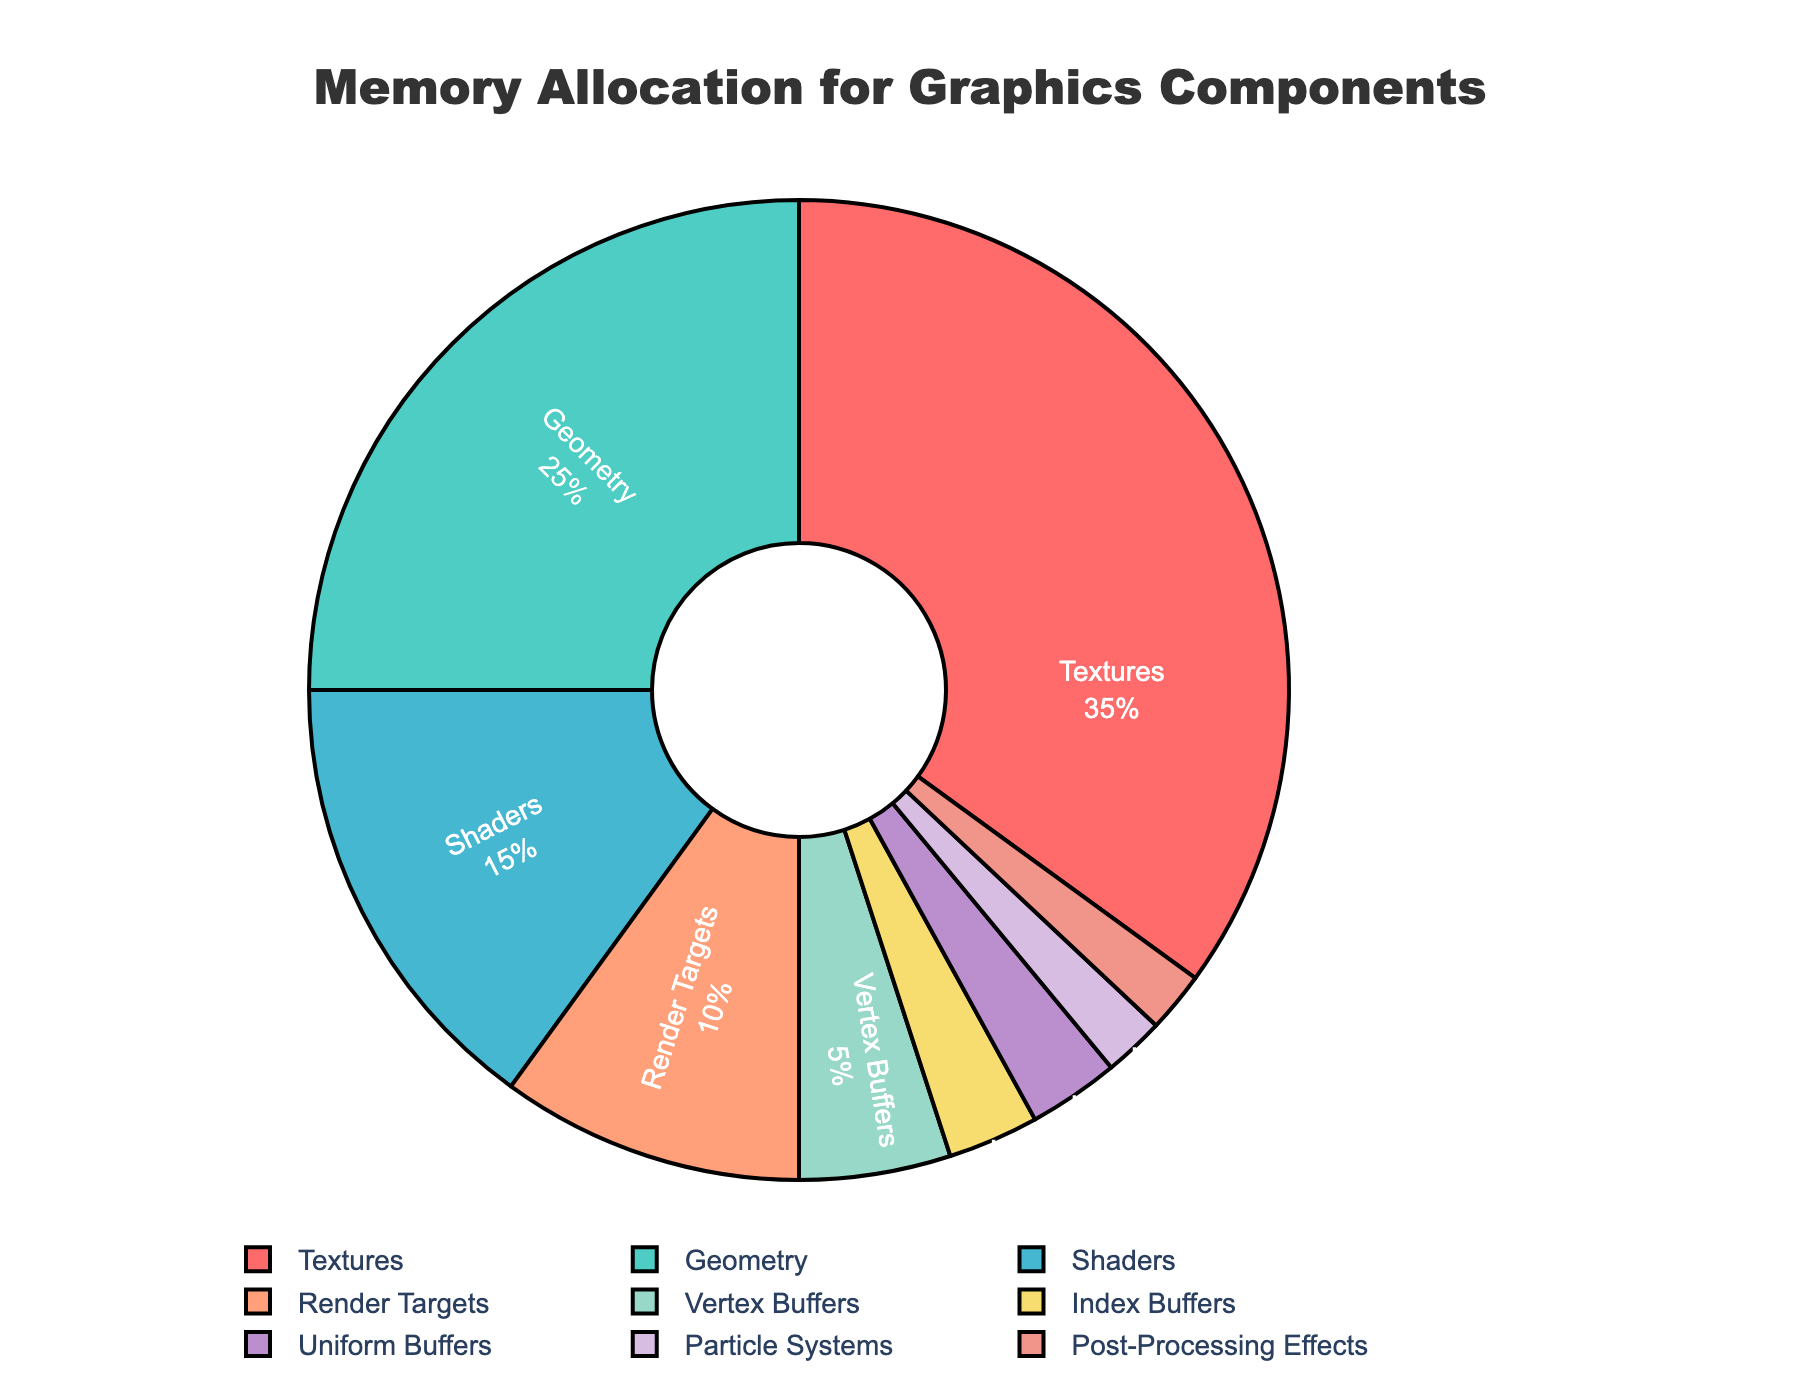Which component uses the most memory? The figure shows that textures use the highest percentage of memory resources at 35%.
Answer: Textures Which two components together use the least amount of memory? The figure shows that particle systems and post-processing effects both use 2% each, totaling 4%, which is the least combined percentage.
Answer: Particle Systems and Post-Processing Effects How much more memory is allocated to textures than to shaders? The figure shows textures use 35% and shaders use 15%. The difference is 35% - 15% = 20%.
Answer: 20% What percentage of memory is allocated to buffers (including vertex buffers, index buffers, and uniform buffers)? The figure shows vertex buffers use 5%, index buffers use 3%, and uniform buffers use 3%. Adding these gives 5% + 3% + 3% = 11%.
Answer: 11% Which component uses exactly 10% of memory resources? The figure indicates that render targets use exactly 10% of memory resources.
Answer: Render Targets Is the memory allocated to geometry more or less than the memory allocated to shaders and render targets combined? Shaders use 15%, render targets use 10%, and their combined total is 25%. Geometry also uses 25%, making it equal.
Answer: Equal What percentage of memory is used by components with less than 5% allocation each? Index buffers (3%), uniform buffers (3%), particle systems (2%), and post-processing effects (2%) each use less than 5%. Summing these: 3% + 3% + 2% + 2% = 10%.
Answer: 10% 